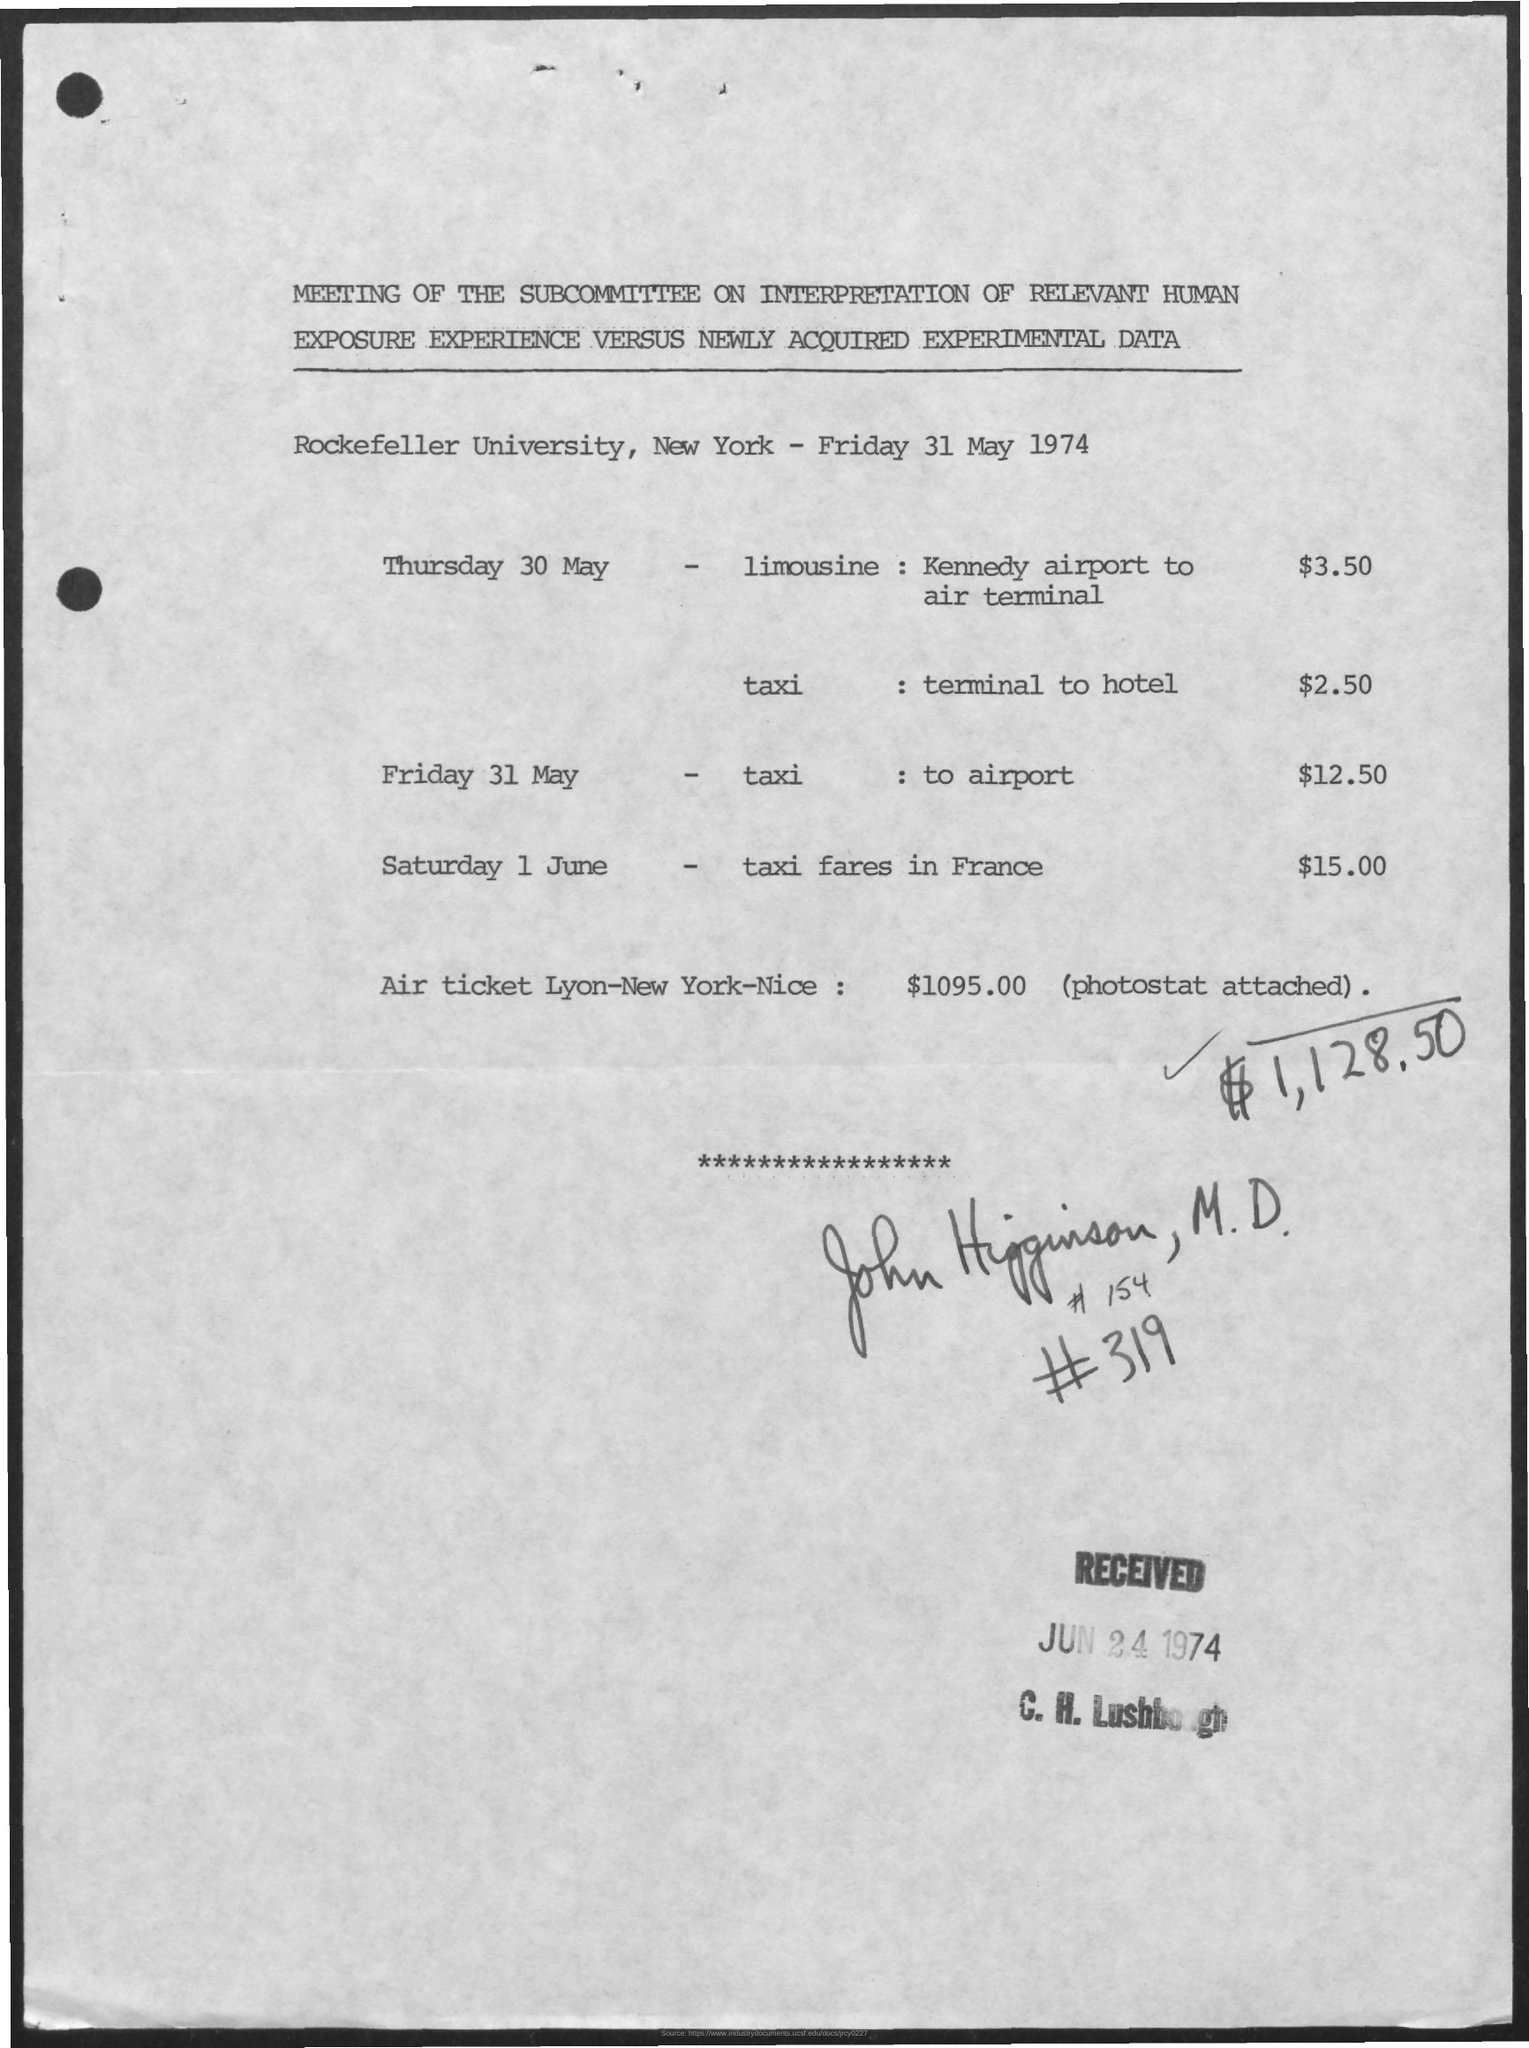What document is depicted in the image? The image shows a document that appears to be a financial statement or ledger from the Rockefeller University detailing transportation expenses for specific dates in May 1974, along with a total including an air ticket from Lyon to New York to Nice. 